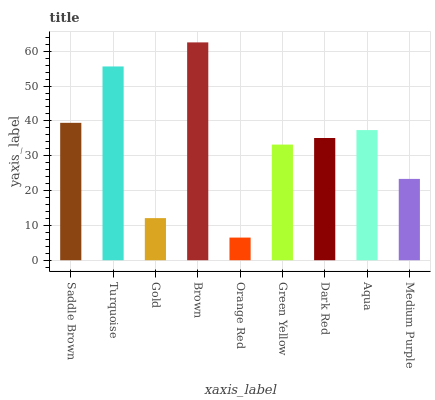Is Orange Red the minimum?
Answer yes or no. Yes. Is Brown the maximum?
Answer yes or no. Yes. Is Turquoise the minimum?
Answer yes or no. No. Is Turquoise the maximum?
Answer yes or no. No. Is Turquoise greater than Saddle Brown?
Answer yes or no. Yes. Is Saddle Brown less than Turquoise?
Answer yes or no. Yes. Is Saddle Brown greater than Turquoise?
Answer yes or no. No. Is Turquoise less than Saddle Brown?
Answer yes or no. No. Is Dark Red the high median?
Answer yes or no. Yes. Is Dark Red the low median?
Answer yes or no. Yes. Is Medium Purple the high median?
Answer yes or no. No. Is Gold the low median?
Answer yes or no. No. 